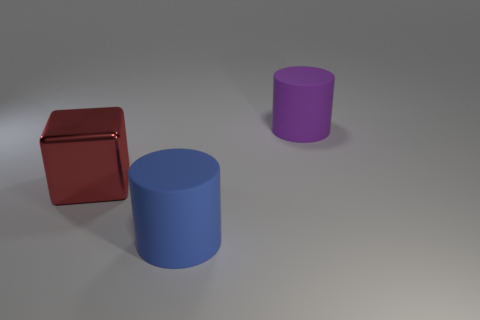Can you tell me what time of day it seems to be based on the lighting in the image? The image does not provide any direct indication of the time of day, as the objects are presented with a neutral background and what appears to be artificial lighting. 